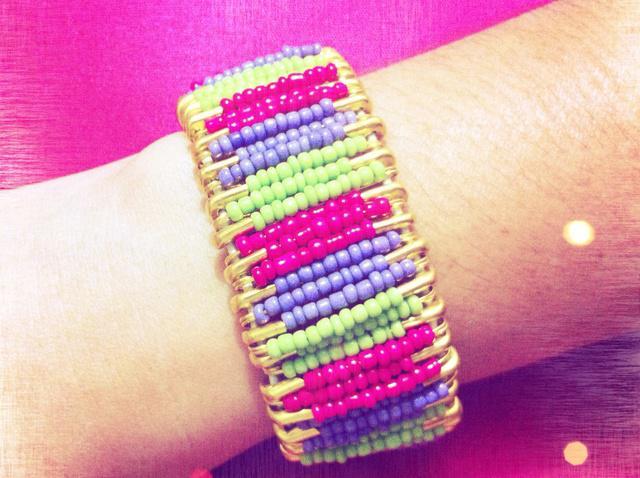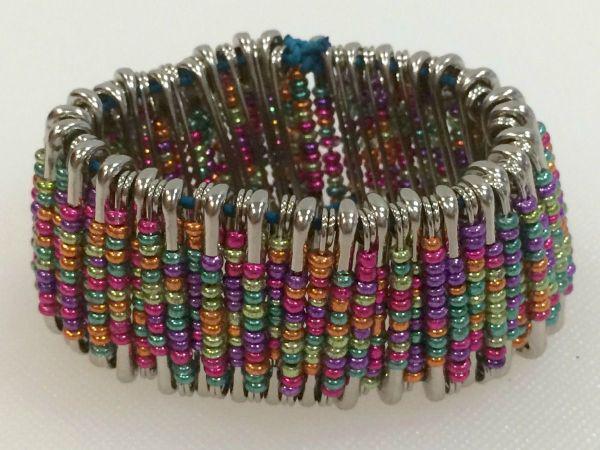The first image is the image on the left, the second image is the image on the right. Considering the images on both sides, is "A bracelet has at least three different colored beads." valid? Answer yes or no. Yes. 